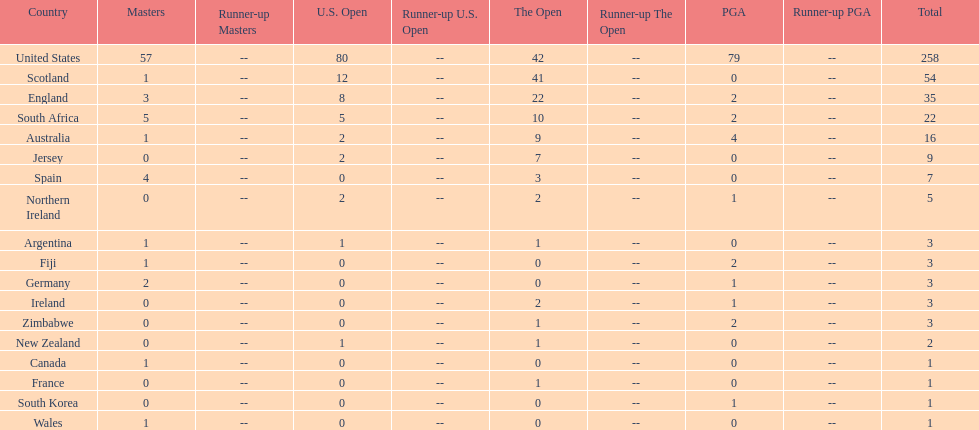Which country has the most pga championships. United States. 